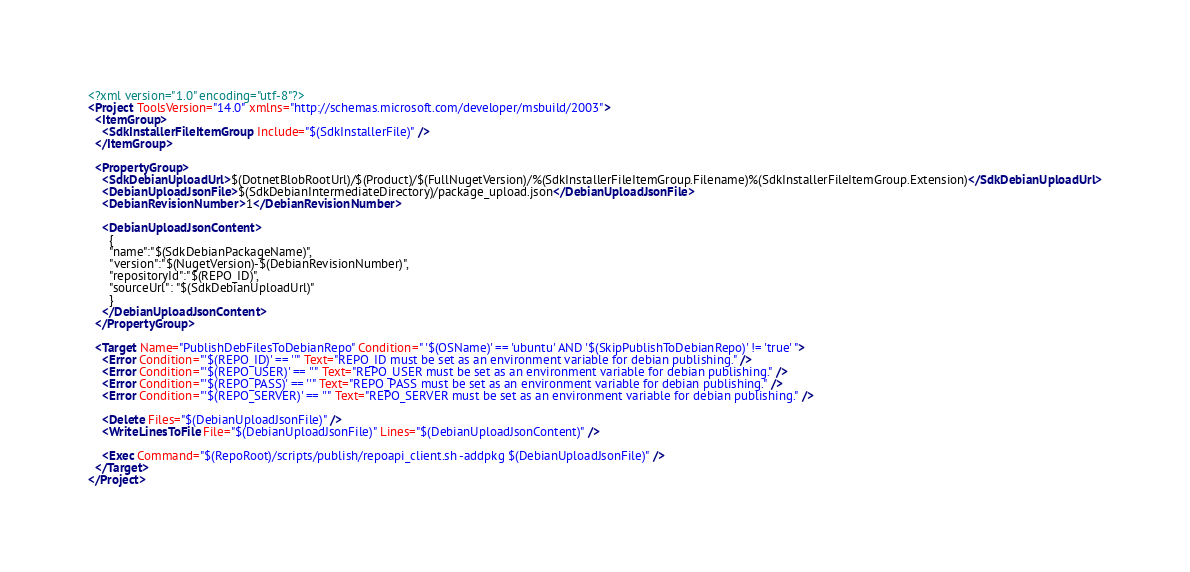Convert code to text. <code><loc_0><loc_0><loc_500><loc_500><_XML_><?xml version="1.0" encoding="utf-8"?>
<Project ToolsVersion="14.0" xmlns="http://schemas.microsoft.com/developer/msbuild/2003">
  <ItemGroup>
    <SdkInstallerFileItemGroup Include="$(SdkInstallerFile)" />
  </ItemGroup>

  <PropertyGroup>
    <SdkDebianUploadUrl>$(DotnetBlobRootUrl)/$(Product)/$(FullNugetVersion)/%(SdkInstallerFileItemGroup.Filename)%(SdkInstallerFileItemGroup.Extension)</SdkDebianUploadUrl>
    <DebianUploadJsonFile>$(SdkDebianIntermediateDirectory)/package_upload.json</DebianUploadJsonFile>
    <DebianRevisionNumber>1</DebianRevisionNumber>

    <DebianUploadJsonContent>
      {
      "name":"$(SdkDebianPackageName)",
      "version":"$(NugetVersion)-$(DebianRevisionNumber)",
      "repositoryId":"$(REPO_ID)",
      "sourceUrl": "$(SdkDebianUploadUrl)"
      }
    </DebianUploadJsonContent>
  </PropertyGroup>

  <Target Name="PublishDebFilesToDebianRepo" Condition=" '$(OSName)' == 'ubuntu' AND '$(SkipPublishToDebianRepo)' != 'true' ">
    <Error Condition="'$(REPO_ID)' == ''" Text="REPO_ID must be set as an environment variable for debian publishing." />
    <Error Condition="'$(REPO_USER)' == ''" Text="REPO_USER must be set as an environment variable for debian publishing." />
    <Error Condition="'$(REPO_PASS)' == ''" Text="REPO_PASS must be set as an environment variable for debian publishing." />
    <Error Condition="'$(REPO_SERVER)' == ''" Text="REPO_SERVER must be set as an environment variable for debian publishing." />

    <Delete Files="$(DebianUploadJsonFile)" />
    <WriteLinesToFile File="$(DebianUploadJsonFile)" Lines="$(DebianUploadJsonContent)" />

    <Exec Command="$(RepoRoot)/scripts/publish/repoapi_client.sh -addpkg $(DebianUploadJsonFile)" />
  </Target>
</Project>
</code> 